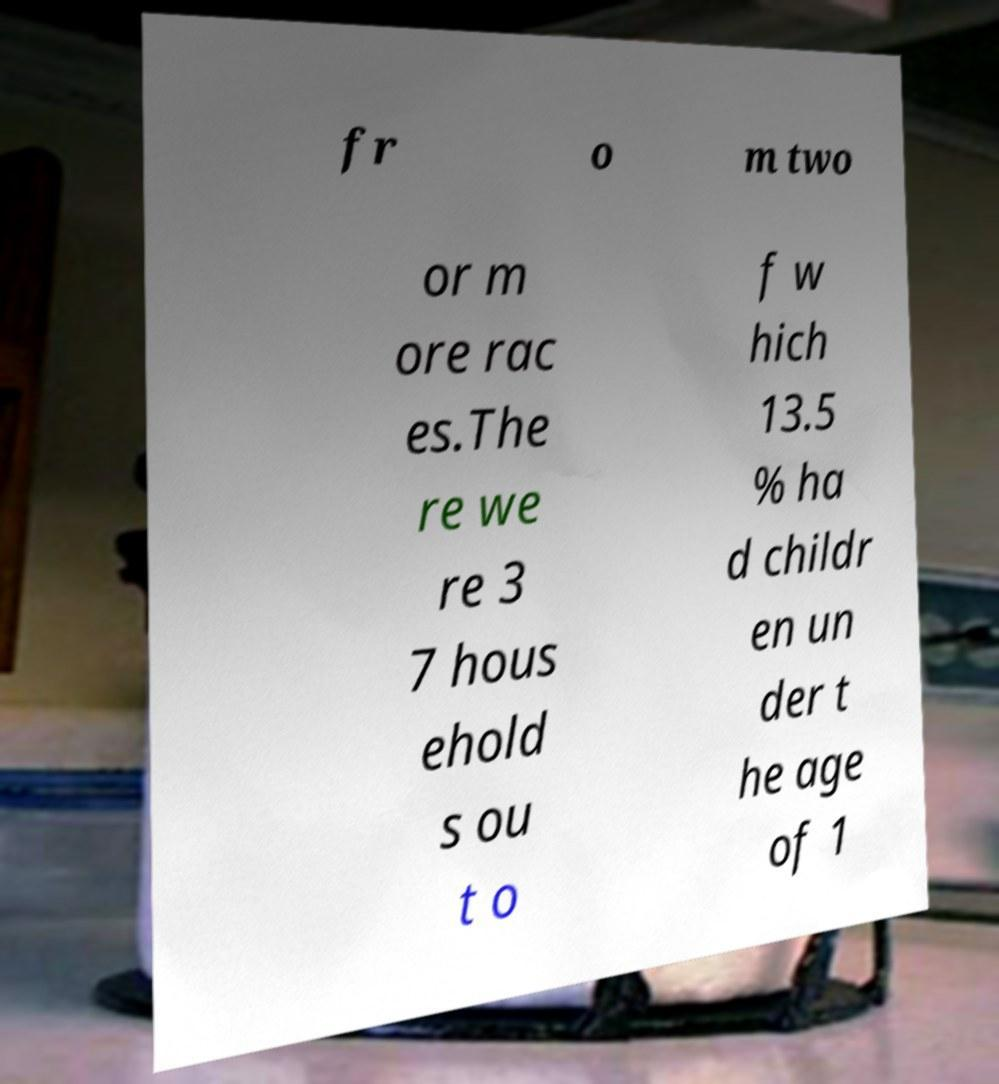Could you assist in decoding the text presented in this image and type it out clearly? fr o m two or m ore rac es.The re we re 3 7 hous ehold s ou t o f w hich 13.5 % ha d childr en un der t he age of 1 